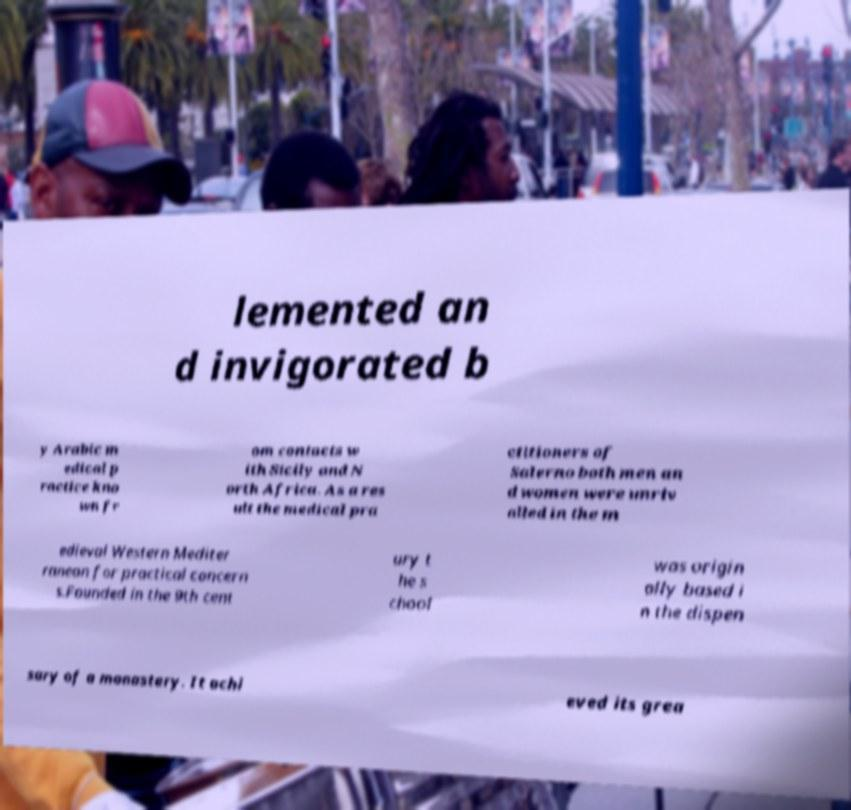Please identify and transcribe the text found in this image. lemented an d invigorated b y Arabic m edical p ractice kno wn fr om contacts w ith Sicily and N orth Africa. As a res ult the medical pra ctitioners of Salerno both men an d women were unriv alled in the m edieval Western Mediter ranean for practical concern s.Founded in the 9th cent ury t he s chool was origin ally based i n the dispen sary of a monastery. It achi eved its grea 